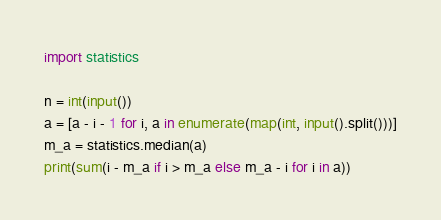<code> <loc_0><loc_0><loc_500><loc_500><_Python_>import statistics

n = int(input())
a = [a - i - 1 for i, a in enumerate(map(int, input().split()))]
m_a = statistics.median(a)
print(sum(i - m_a if i > m_a else m_a - i for i in a))
</code> 